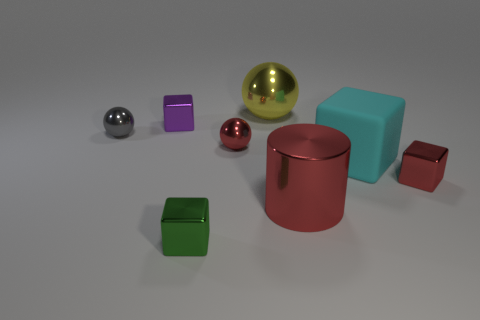Is there any other thing that has the same material as the cyan thing?
Offer a very short reply. No. What is the material of the big object to the right of the large red metal cylinder?
Ensure brevity in your answer.  Rubber. The red metal object that is to the left of the tiny red metallic cube and in front of the large cyan rubber cube has what shape?
Provide a short and direct response. Cylinder. What is the material of the purple thing?
Offer a very short reply. Metal. What number of cylinders are big red objects or big yellow things?
Your answer should be very brief. 1. Is the material of the large cyan thing the same as the small gray thing?
Offer a very short reply. No. There is a purple shiny thing that is the same shape as the small green metallic thing; what is its size?
Keep it short and to the point. Small. There is a large object that is both behind the big red cylinder and in front of the gray metallic object; what material is it?
Provide a short and direct response. Rubber. Are there an equal number of cyan cubes that are in front of the large block and large blue rubber cylinders?
Your answer should be very brief. Yes. What number of objects are either tiny objects that are left of the green shiny thing or rubber objects?
Your response must be concise. 3. 